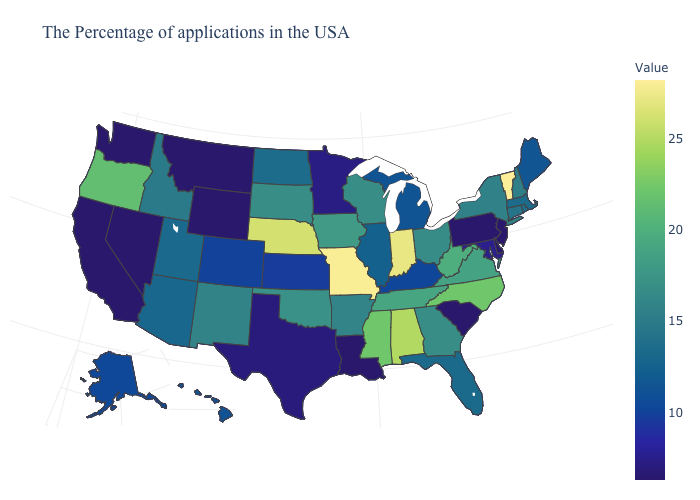Which states have the lowest value in the USA?
Quick response, please. New Jersey, Delaware, Pennsylvania, South Carolina, Louisiana, Wyoming, Montana, Nevada, California, Washington. Does the map have missing data?
Answer briefly. No. Which states hav the highest value in the Northeast?
Short answer required. Vermont. Which states have the lowest value in the USA?
Concise answer only. New Jersey, Delaware, Pennsylvania, South Carolina, Louisiana, Wyoming, Montana, Nevada, California, Washington. 